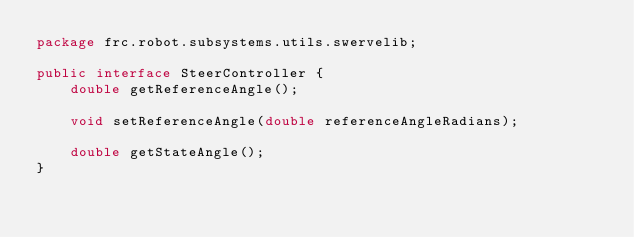<code> <loc_0><loc_0><loc_500><loc_500><_Java_>package frc.robot.subsystems.utils.swervelib;

public interface SteerController {
    double getReferenceAngle();

    void setReferenceAngle(double referenceAngleRadians);

    double getStateAngle();
}
</code> 